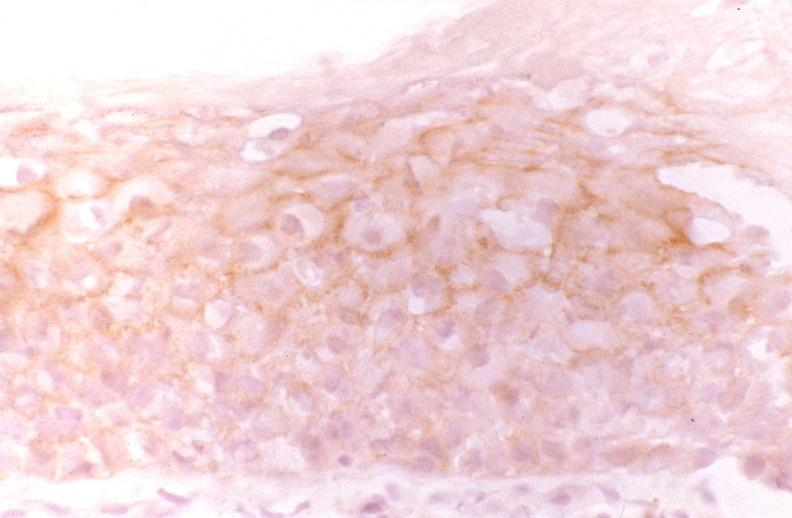does silver show oral dysplasia, neu?
Answer the question using a single word or phrase. No 